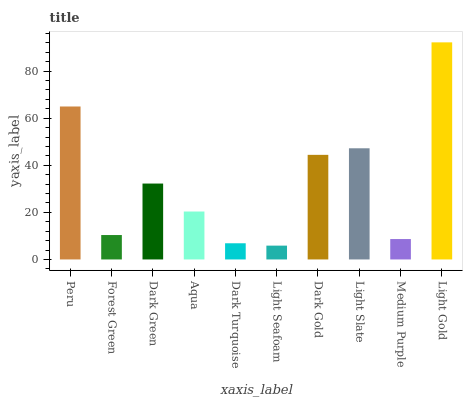Is Light Seafoam the minimum?
Answer yes or no. Yes. Is Light Gold the maximum?
Answer yes or no. Yes. Is Forest Green the minimum?
Answer yes or no. No. Is Forest Green the maximum?
Answer yes or no. No. Is Peru greater than Forest Green?
Answer yes or no. Yes. Is Forest Green less than Peru?
Answer yes or no. Yes. Is Forest Green greater than Peru?
Answer yes or no. No. Is Peru less than Forest Green?
Answer yes or no. No. Is Dark Green the high median?
Answer yes or no. Yes. Is Aqua the low median?
Answer yes or no. Yes. Is Aqua the high median?
Answer yes or no. No. Is Peru the low median?
Answer yes or no. No. 